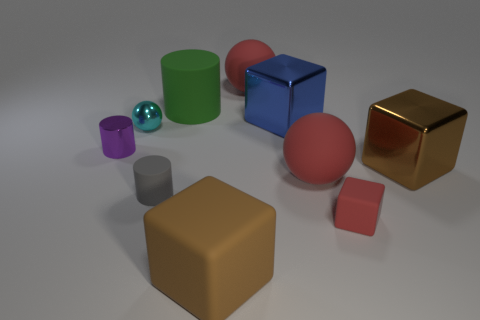Subtract all spheres. How many objects are left? 7 Add 4 brown things. How many brown things are left? 6 Add 1 big metallic objects. How many big metallic objects exist? 3 Subtract 2 red spheres. How many objects are left? 8 Subtract all brown shiny things. Subtract all large red balls. How many objects are left? 7 